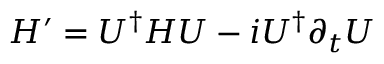Convert formula to latex. <formula><loc_0><loc_0><loc_500><loc_500>H ^ { \prime } = U ^ { \dag } H U - i U ^ { \dag } \partial _ { t } U</formula> 